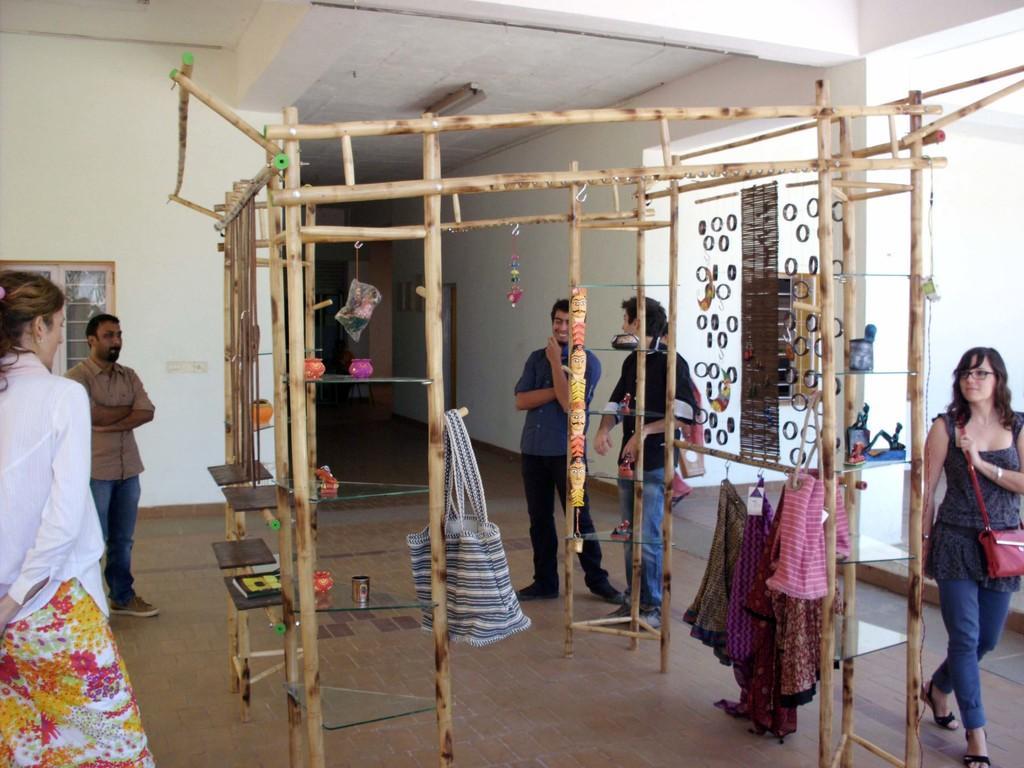Please provide a concise description of this image. In the picture we can see under the house with some pole construction with some handbags and some clothes are hanged for it and around it we can see a few people are standing and watching it and behind it, we can see the wall with a part of the window and opposite side of it we can see the pillar and some things are placed near it. 